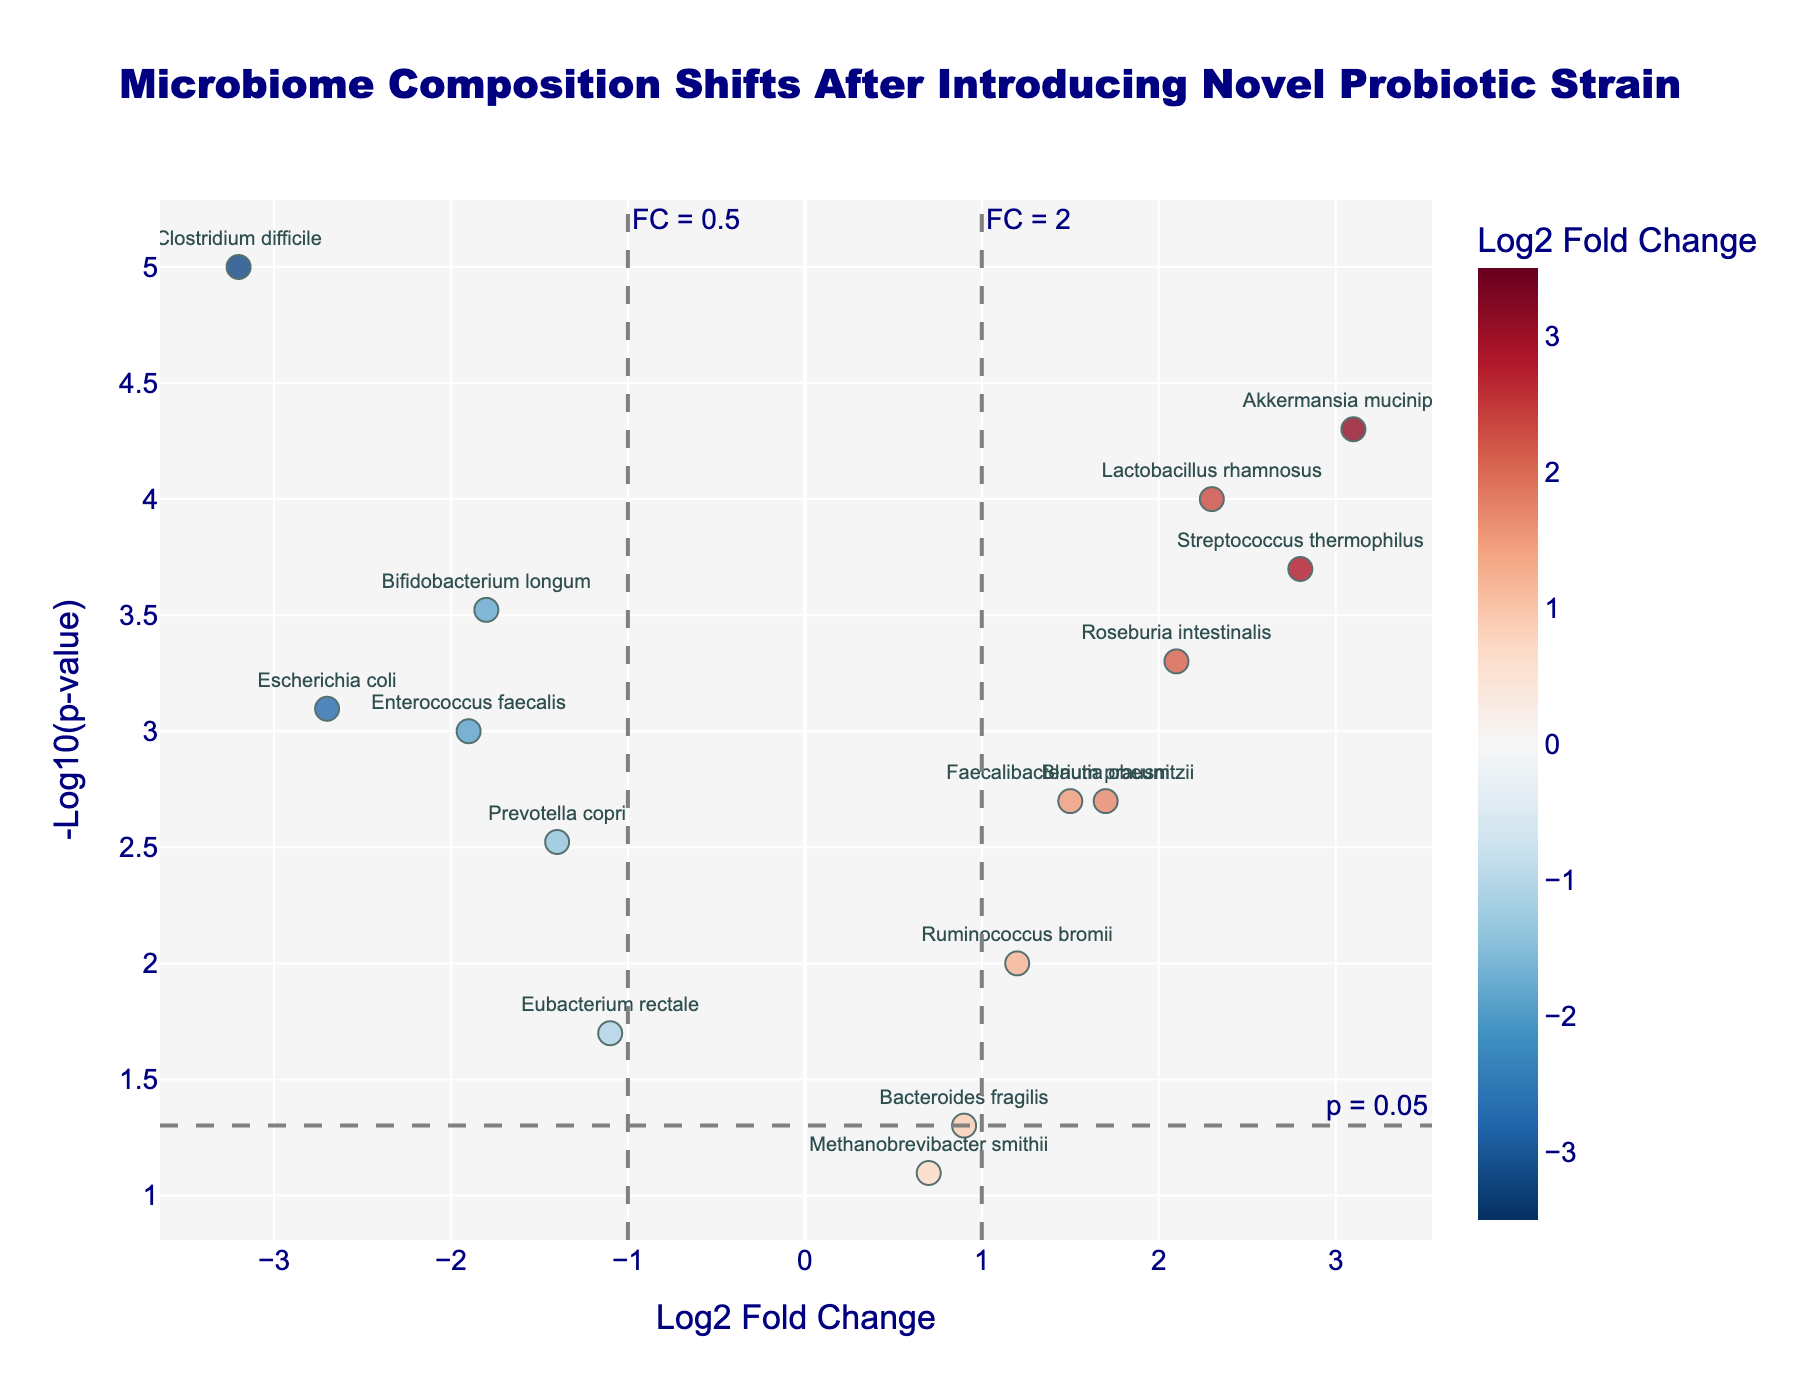What's the title of the figure? The title is usually located at the top of the figure. In this case, it is centered and detailed in the step where the title is set using `fig.update_layout`.
Answer: Microbiome Composition Shifts After Introducing Novel Probiotic Strain What does the x-axis represent? The x-axis label is defined towards the end of the `update_layout` method, indicating that the x-axis represents "Log2 Fold Change".
Answer: Log2 Fold Change Which gene has the highest -Log10(p-value)? By examining the figure, locate the point with the highest y-axis value, which translates to the highest -Log10(p-value).
Answer: Clostridium difficile How many genes have a Log2 Fold Change greater than 1? To find this, count the number of points to the right of the vertical line at x = 1. Looking at the visual spread of data points, you can verify the genes beyond this threshold.
Answer: 5 Which gene has the largest negative Log2 Fold Change? The gene with the largest negative value on the x-axis will be the leftmost point on the plot.
Answer: Clostridium difficile What threshold line indicates the significance at p = 0.05? The threshold line for p = 0.05 is marked by the horizontal dashed line, as set in the `add_hline` method.
Answer: -Log10(p-value) of 1.3 Which genes fall into the top right quadrant of the plot? The top-right quadrant consists of genes with positive Log2 Fold Change and high -Log10(p-values), evident from their positions relative to the dashed lines.
Answer: Lactobacillus rhamnosus, Akkermansia muciniphila, Streptococcus thermophilus, Roseburia intestinalis Compare the p-values of Faecalibacterium prausnitzii and Eubacterium rectale. Which one is more significant? To determine significance, compare their -Log10(p-values). Higher -Log10(p-value) implies more significance, which is deduced from the visual positions on the y-axis.
Answer: Faecalibacterium prausnitzii 